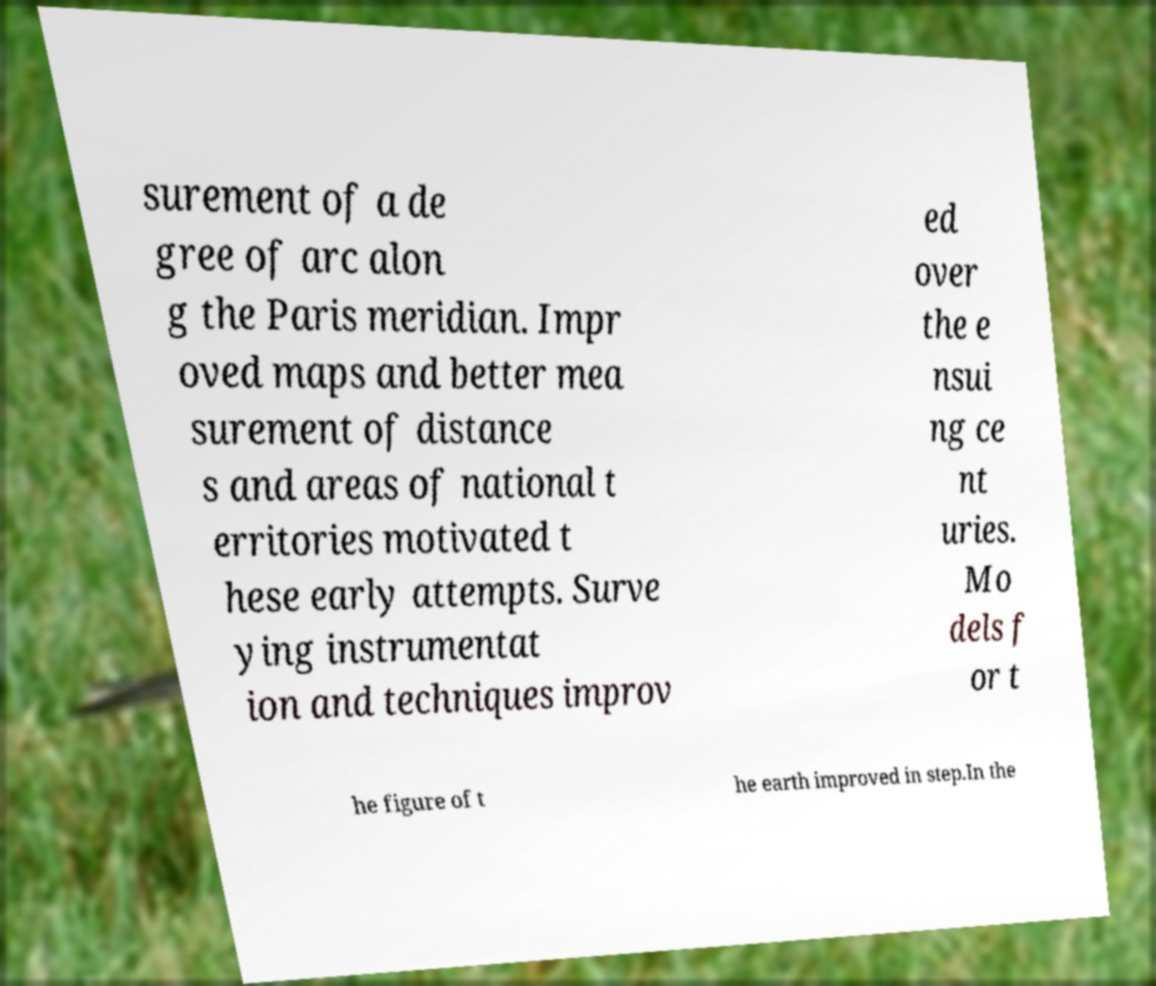For documentation purposes, I need the text within this image transcribed. Could you provide that? surement of a de gree of arc alon g the Paris meridian. Impr oved maps and better mea surement of distance s and areas of national t erritories motivated t hese early attempts. Surve ying instrumentat ion and techniques improv ed over the e nsui ng ce nt uries. Mo dels f or t he figure of t he earth improved in step.In the 